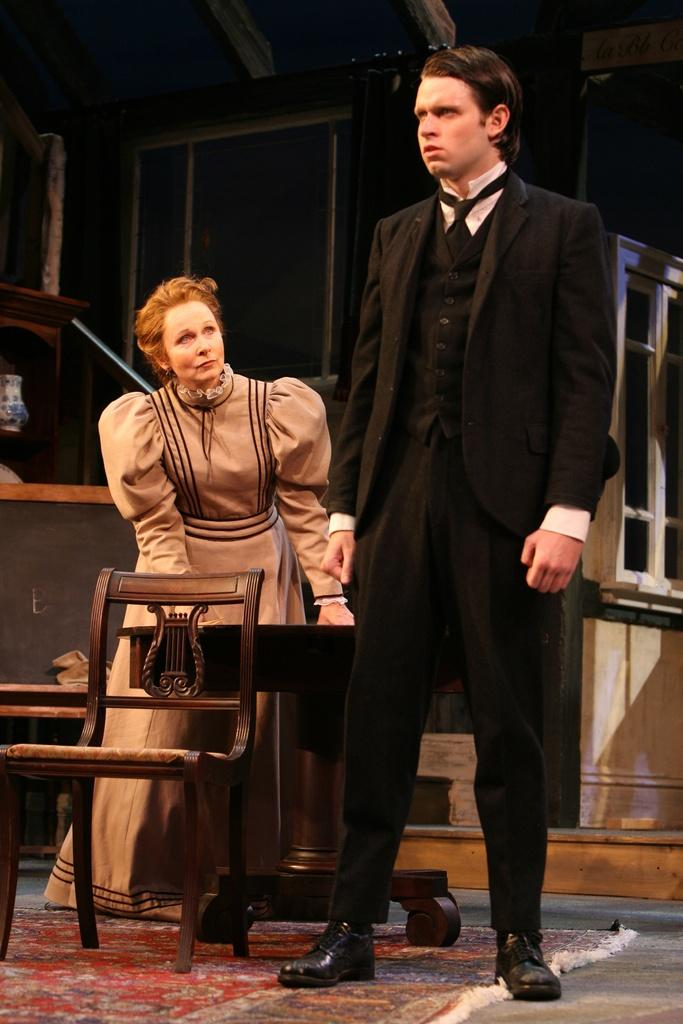Who are the people in the image? There is a woman and a man in the image. What is the woman doing in the image? The woman is looking at the man in the image. What type of furniture is present in the image? There is a chair and tables visible in the image. What material can be seen in the background of the image? There are wooden objects in the background of the image. What time of day is depicted in the image, and what hour is it? The provided facts do not mention the time of day or any specific hour. What type of leaf can be seen falling from the ceiling in the image? There is no leaf present in the image; it only features a woman, a man, a chair, tables, and wooden objects in the background. 